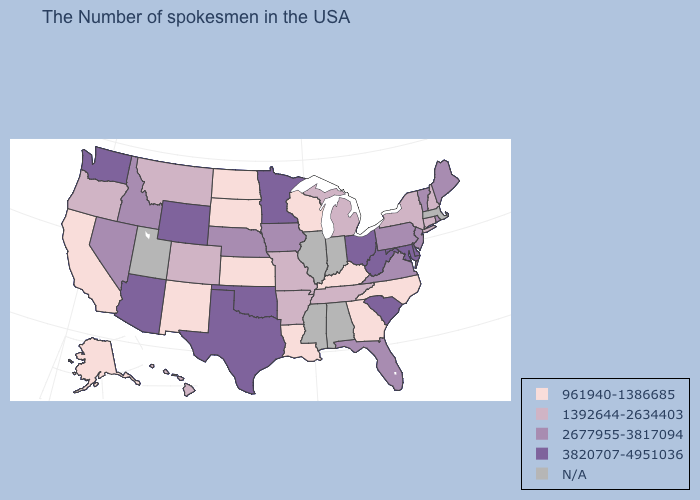Which states have the lowest value in the MidWest?
Short answer required. Wisconsin, Kansas, South Dakota, North Dakota. Which states have the lowest value in the USA?
Keep it brief. North Carolina, Georgia, Kentucky, Wisconsin, Louisiana, Kansas, South Dakota, North Dakota, New Mexico, California, Alaska. Does the map have missing data?
Quick response, please. Yes. Name the states that have a value in the range 3820707-4951036?
Give a very brief answer. Delaware, Maryland, South Carolina, West Virginia, Ohio, Minnesota, Oklahoma, Texas, Wyoming, Arizona, Washington. Which states have the lowest value in the USA?
Be succinct. North Carolina, Georgia, Kentucky, Wisconsin, Louisiana, Kansas, South Dakota, North Dakota, New Mexico, California, Alaska. Which states have the highest value in the USA?
Quick response, please. Delaware, Maryland, South Carolina, West Virginia, Ohio, Minnesota, Oklahoma, Texas, Wyoming, Arizona, Washington. Name the states that have a value in the range 3820707-4951036?
Write a very short answer. Delaware, Maryland, South Carolina, West Virginia, Ohio, Minnesota, Oklahoma, Texas, Wyoming, Arizona, Washington. Among the states that border Montana , which have the lowest value?
Concise answer only. South Dakota, North Dakota. Among the states that border Vermont , which have the lowest value?
Write a very short answer. New Hampshire, New York. What is the value of Michigan?
Answer briefly. 1392644-2634403. What is the value of California?
Keep it brief. 961940-1386685. Name the states that have a value in the range 3820707-4951036?
Write a very short answer. Delaware, Maryland, South Carolina, West Virginia, Ohio, Minnesota, Oklahoma, Texas, Wyoming, Arizona, Washington. Name the states that have a value in the range 3820707-4951036?
Short answer required. Delaware, Maryland, South Carolina, West Virginia, Ohio, Minnesota, Oklahoma, Texas, Wyoming, Arizona, Washington. Does Rhode Island have the highest value in the Northeast?
Give a very brief answer. Yes. 